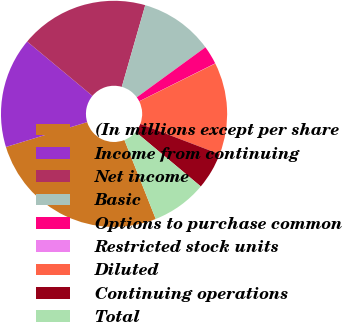<chart> <loc_0><loc_0><loc_500><loc_500><pie_chart><fcel>(In millions except per share<fcel>Income from continuing<fcel>Net income<fcel>Basic<fcel>Options to purchase common<fcel>Restricted stock units<fcel>Diluted<fcel>Continuing operations<fcel>Total<nl><fcel>26.28%<fcel>15.78%<fcel>18.4%<fcel>10.53%<fcel>2.65%<fcel>0.03%<fcel>13.15%<fcel>5.28%<fcel>7.9%<nl></chart> 